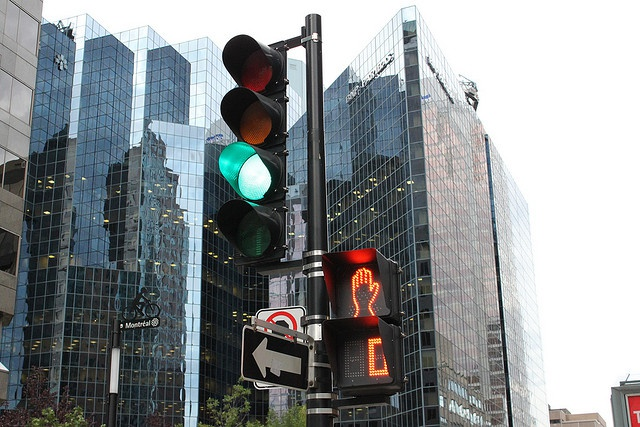Describe the objects in this image and their specific colors. I can see traffic light in darkgray, black, white, maroon, and gray tones, traffic light in darkgray, black, gray, maroon, and red tones, and stop sign in darkgray, lightgray, red, and black tones in this image. 